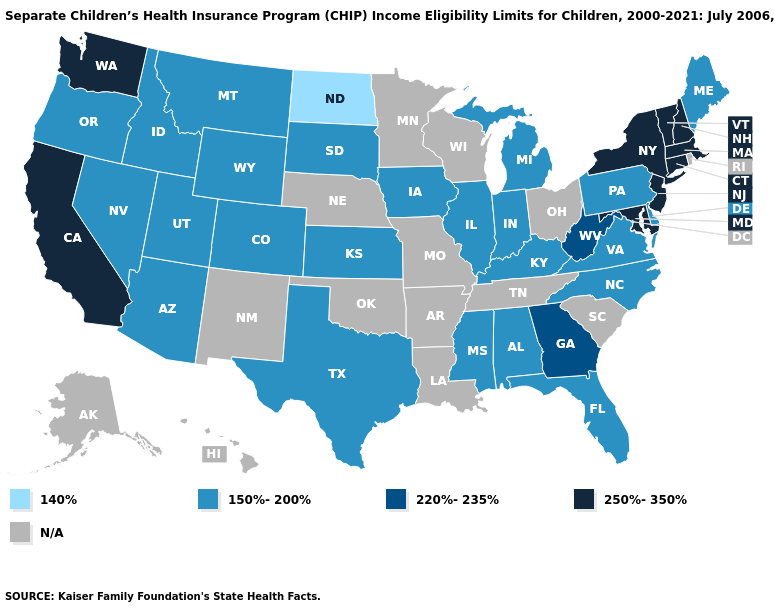Does Georgia have the lowest value in the South?
Be succinct. No. Does Maryland have the lowest value in the South?
Quick response, please. No. What is the value of Delaware?
Write a very short answer. 150%-200%. Among the states that border Massachusetts , which have the highest value?
Quick response, please. Connecticut, New Hampshire, New York, Vermont. Does the first symbol in the legend represent the smallest category?
Give a very brief answer. Yes. What is the value of Alaska?
Quick response, please. N/A. Among the states that border Utah , which have the highest value?
Write a very short answer. Arizona, Colorado, Idaho, Nevada, Wyoming. What is the value of South Carolina?
Answer briefly. N/A. Which states have the lowest value in the USA?
Quick response, please. North Dakota. What is the highest value in the Northeast ?
Answer briefly. 250%-350%. 